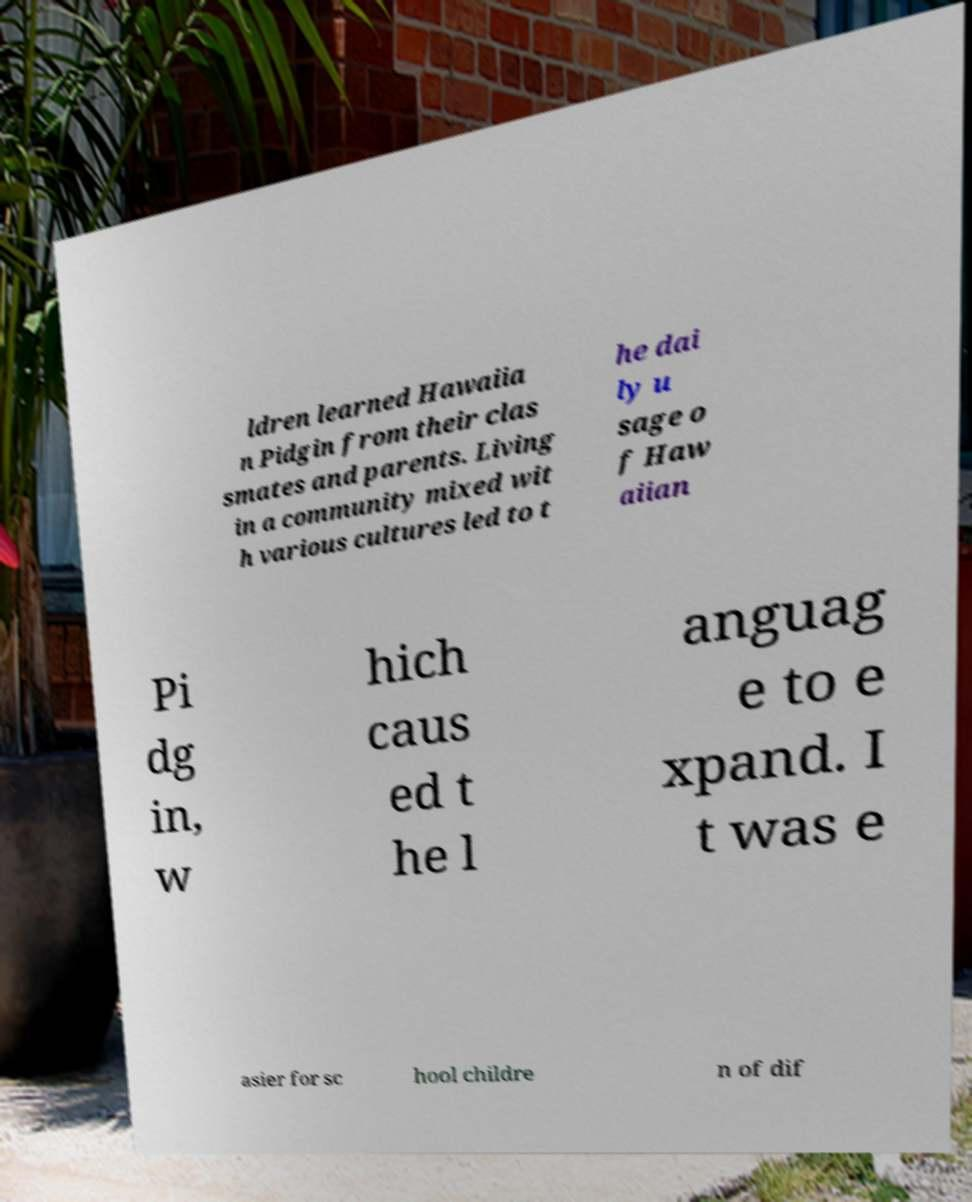Could you assist in decoding the text presented in this image and type it out clearly? ldren learned Hawaiia n Pidgin from their clas smates and parents. Living in a community mixed wit h various cultures led to t he dai ly u sage o f Haw aiian Pi dg in, w hich caus ed t he l anguag e to e xpand. I t was e asier for sc hool childre n of dif 